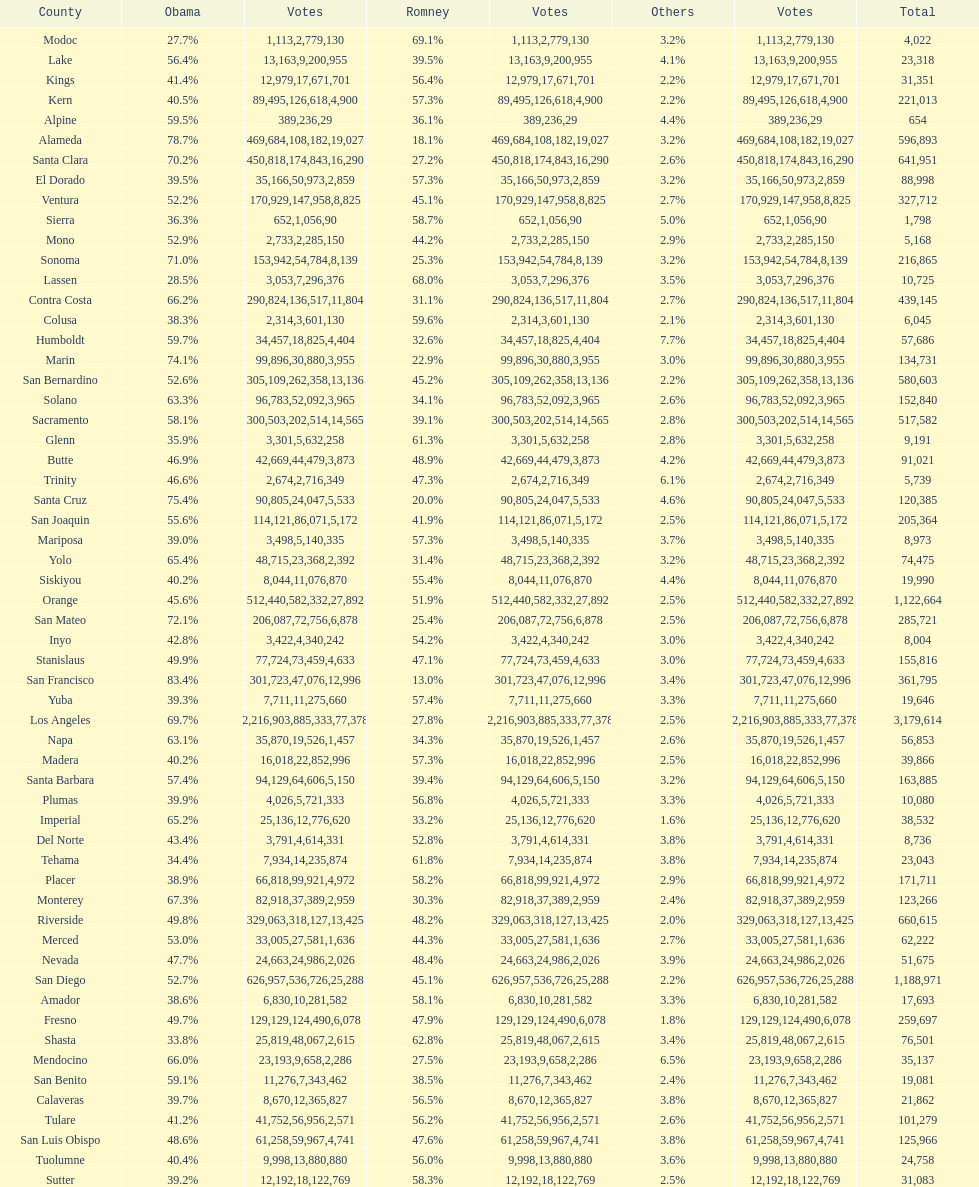What is the number of votes for obama for del norte and el dorado counties? 38957. 